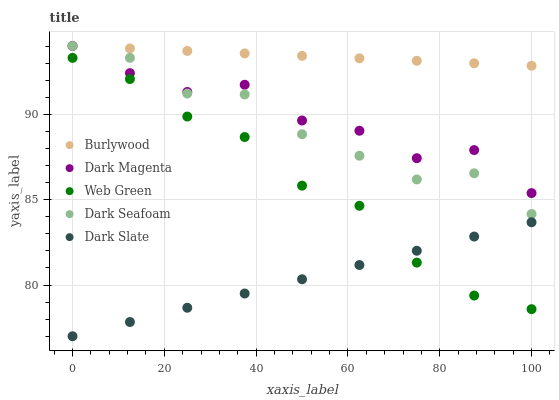Does Dark Slate have the minimum area under the curve?
Answer yes or no. Yes. Does Burlywood have the maximum area under the curve?
Answer yes or no. Yes. Does Dark Seafoam have the minimum area under the curve?
Answer yes or no. No. Does Dark Seafoam have the maximum area under the curve?
Answer yes or no. No. Is Burlywood the smoothest?
Answer yes or no. Yes. Is Dark Magenta the roughest?
Answer yes or no. Yes. Is Dark Slate the smoothest?
Answer yes or no. No. Is Dark Slate the roughest?
Answer yes or no. No. Does Dark Slate have the lowest value?
Answer yes or no. Yes. Does Dark Seafoam have the lowest value?
Answer yes or no. No. Does Dark Magenta have the highest value?
Answer yes or no. Yes. Does Dark Slate have the highest value?
Answer yes or no. No. Is Web Green less than Dark Magenta?
Answer yes or no. Yes. Is Burlywood greater than Web Green?
Answer yes or no. Yes. Does Dark Slate intersect Web Green?
Answer yes or no. Yes. Is Dark Slate less than Web Green?
Answer yes or no. No. Is Dark Slate greater than Web Green?
Answer yes or no. No. Does Web Green intersect Dark Magenta?
Answer yes or no. No. 